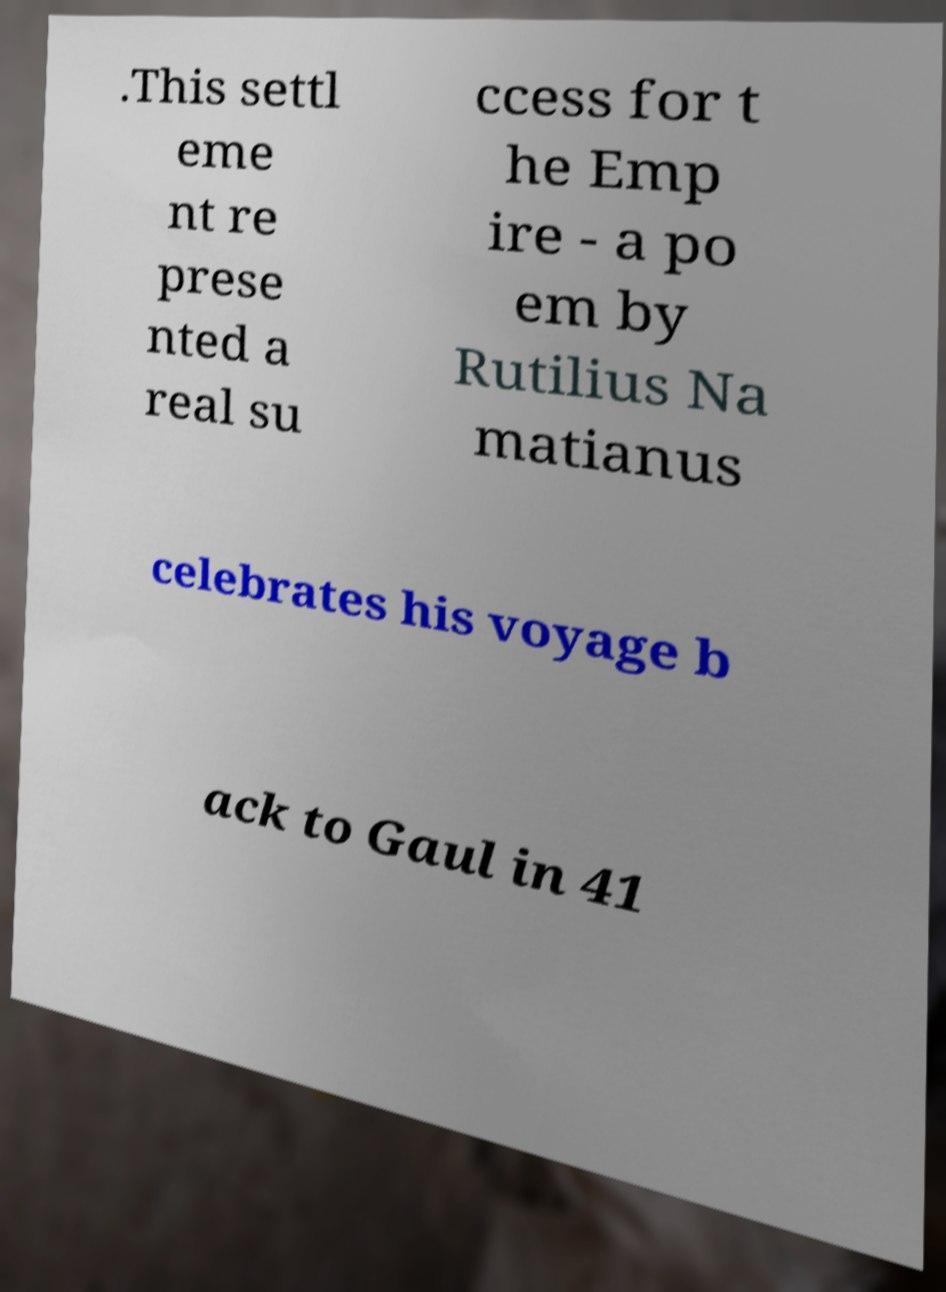What messages or text are displayed in this image? I need them in a readable, typed format. .This settl eme nt re prese nted a real su ccess for t he Emp ire - a po em by Rutilius Na matianus celebrates his voyage b ack to Gaul in 41 